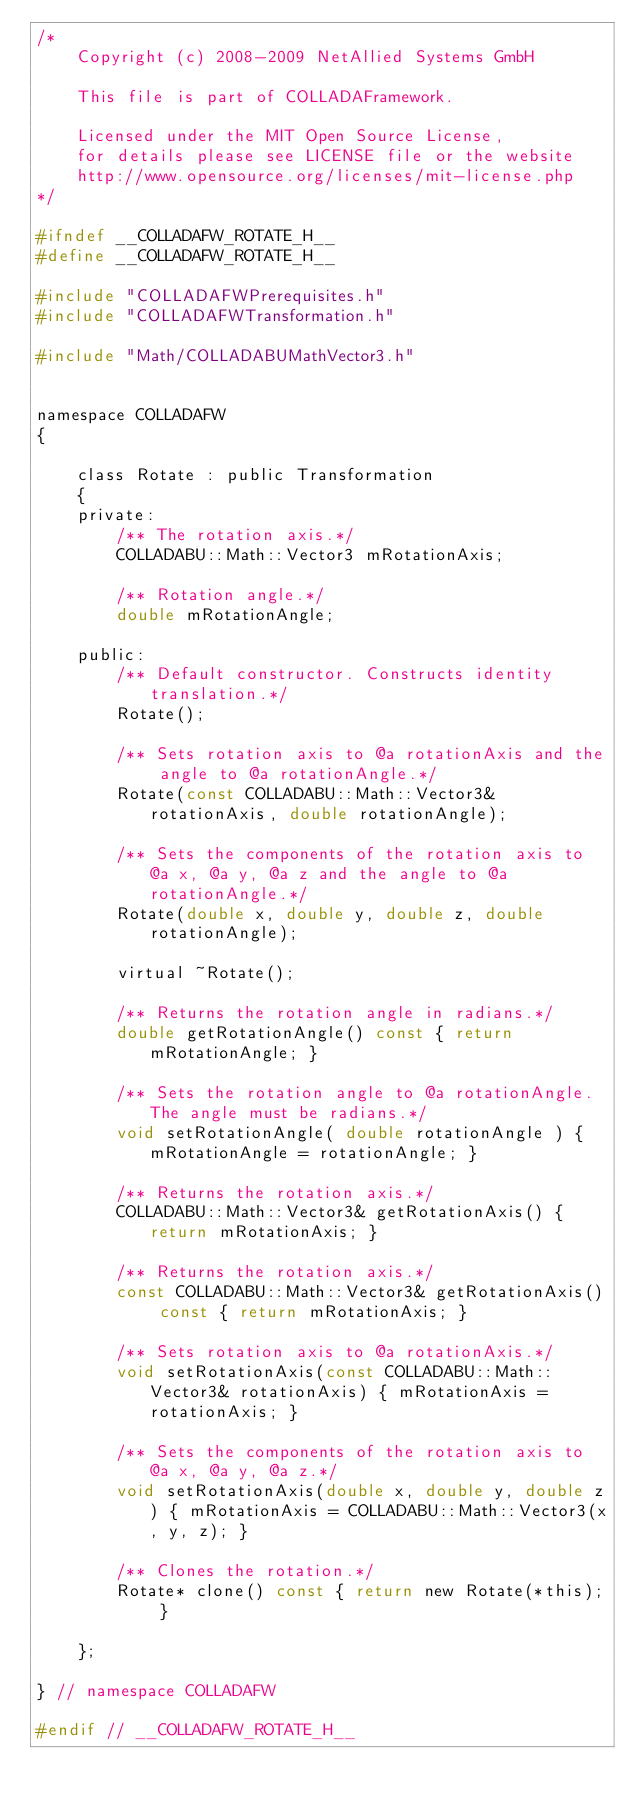<code> <loc_0><loc_0><loc_500><loc_500><_C_>/*
    Copyright (c) 2008-2009 NetAllied Systems GmbH

    This file is part of COLLADAFramework.

    Licensed under the MIT Open Source License, 
    for details please see LICENSE file or the website
    http://www.opensource.org/licenses/mit-license.php
*/

#ifndef __COLLADAFW_ROTATE_H__
#define __COLLADAFW_ROTATE_H__

#include "COLLADAFWPrerequisites.h"
#include "COLLADAFWTransformation.h"

#include "Math/COLLADABUMathVector3.h"


namespace COLLADAFW
{

	class Rotate : public Transformation
	{
	private:
		/** The rotation axis.*/
        COLLADABU::Math::Vector3 mRotationAxis;

		/** Rotation angle.*/
		double mRotationAngle;
	
	public:
		/** Default constructor. Constructs identity translation.*/ 
		Rotate();

		/** Sets rotation axis to @a rotationAxis and the angle to @a rotationAngle.*/ 
		Rotate(const COLLADABU::Math::Vector3& rotationAxis, double rotationAngle);

		/** Sets the components of the rotation axis to @a x, @a y, @a z and the angle to @a rotationAngle.*/
		Rotate(double x, double y, double z, double rotationAngle);

		virtual ~Rotate();

		/** Returns the rotation angle in radians.*/
		double getRotationAngle() const { return mRotationAngle; }

		/** Sets the rotation angle to @a rotationAngle. The angle must be radians.*/
		void setRotationAngle( double rotationAngle ) { mRotationAngle = rotationAngle; }

		/** Returns the rotation axis.*/
		COLLADABU::Math::Vector3& getRotationAxis() { return mRotationAxis; }

		/** Returns the rotation axis.*/
		const COLLADABU::Math::Vector3& getRotationAxis() const { return mRotationAxis; }

		/** Sets rotation axis to @a rotationAxis.*/
		void setRotationAxis(const COLLADABU::Math::Vector3& rotationAxis) { mRotationAxis = rotationAxis; }

		/** Sets the components of the rotation axis to @a x, @a y, @a z.*/
		void setRotationAxis(double x, double y, double z) { mRotationAxis = COLLADABU::Math::Vector3(x, y, z); }

		/** Clones the rotation.*/
		Rotate* clone() const { return new Rotate(*this); }

	};

} // namespace COLLADAFW

#endif // __COLLADAFW_ROTATE_H__
</code> 